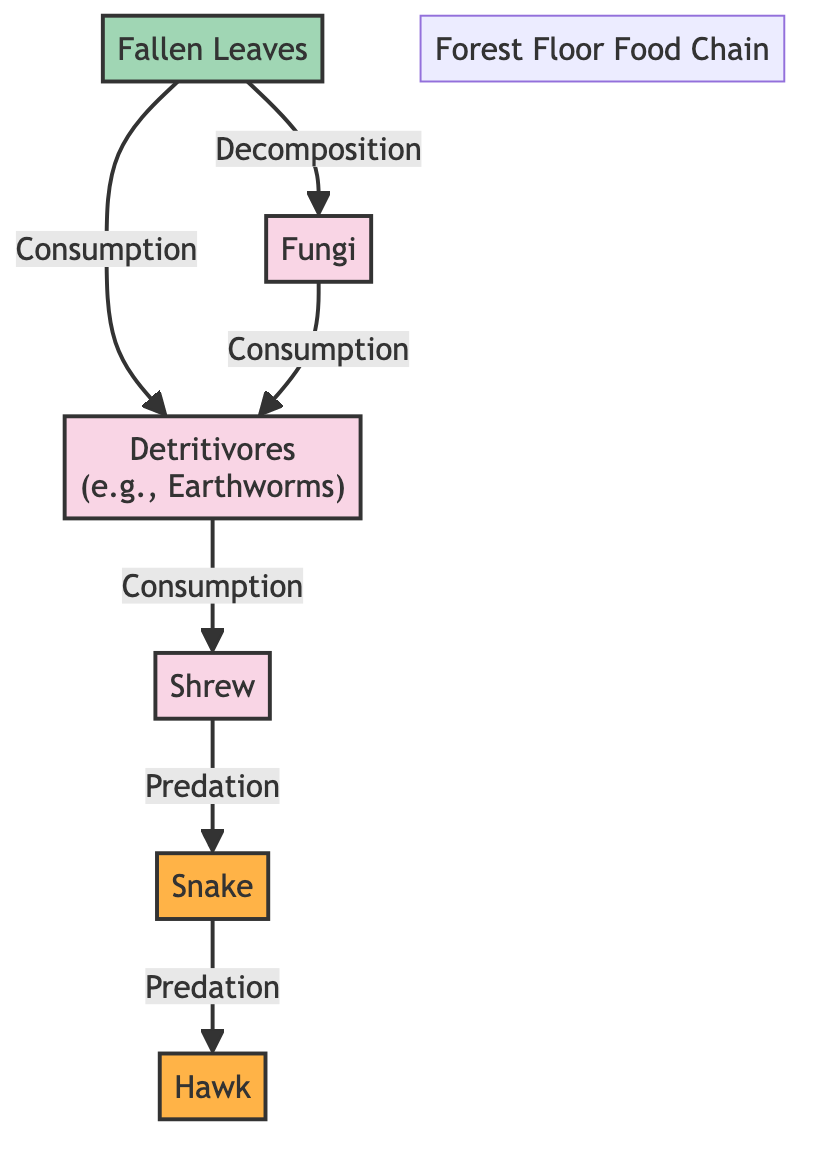What is the first node in the food chain? The first node in the food chain is "Fallen Leaves," which serves as the primary source of energy for the ecosystem.
Answer: Fallen Leaves How many predator nodes are in the diagram? There are two predator nodes in the diagram, which are "Snake" and "Hawk." Each of these organisms is at the top of their respective energy paths in the food chain.
Answer: 2 What do fungi consume in the food chain? Fungi consume "Fallen Leaves" and also receive nutrients from "Detritivores," thereby participating in the breakdown of organic matter in this ecosystem.
Answer: Fallen Leaves, Detritivores Which organism is directly preyed upon by the snake? The organism directly preyed upon by the snake is the "Shrew," which is positioned just below the snake in the food chain hierarchy.
Answer: Shrew What is the relationship between fallen leaves and fungi? The relationship is defined as "Decomposition," where fallen leaves are broken down by fungi, recycling nutrients back into the ecosystem.
Answer: Decomposition How do detritivores fit into this food chain? Detritivores consume both "Fallen Leaves" and "Fungi," serving as a crucial link in the food chain by decomposing organic matter and transferring energy to higher trophic levels, such as the shrew.
Answer: Consumers of Fallen Leaves, Fungi Which node has two arrows leading to it, and what are they? The node "Detritivores" has two arrows leading to it; one from "Fallen Leaves" and another from "Fungi," indicating it derives energy from both sources.
Answer: Detritivores; Fallen Leaves, Fungi What is the final predator in this food chain? The final predator in this food chain is the "Hawk," which is the top predator, consuming energy from the "Snake."
Answer: Hawk What is the primary role of fallen leaves in this ecosystem? The primary role of fallen leaves in this ecosystem is to act as a producer by providing energy through decomposition, initiating the food chain.
Answer: Producer of energy 